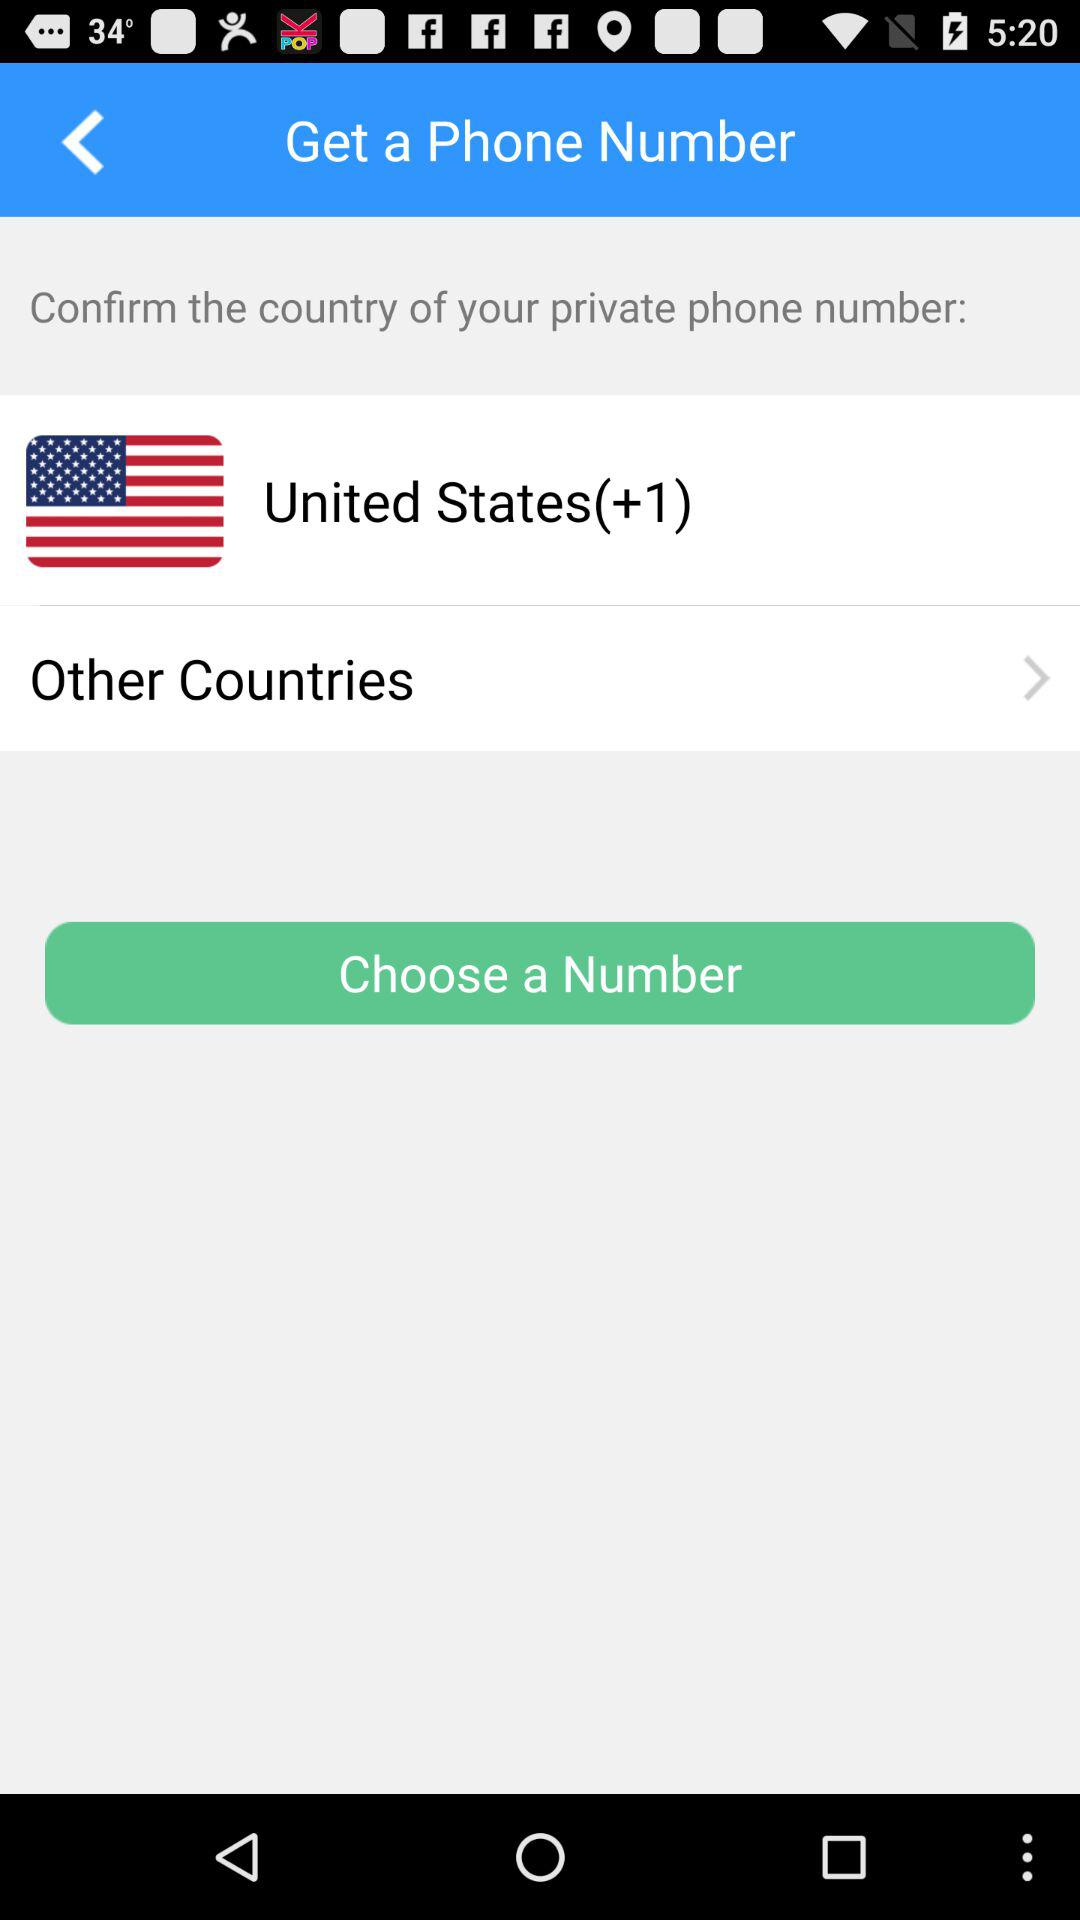Which country is selected? The selected country is the United States. 